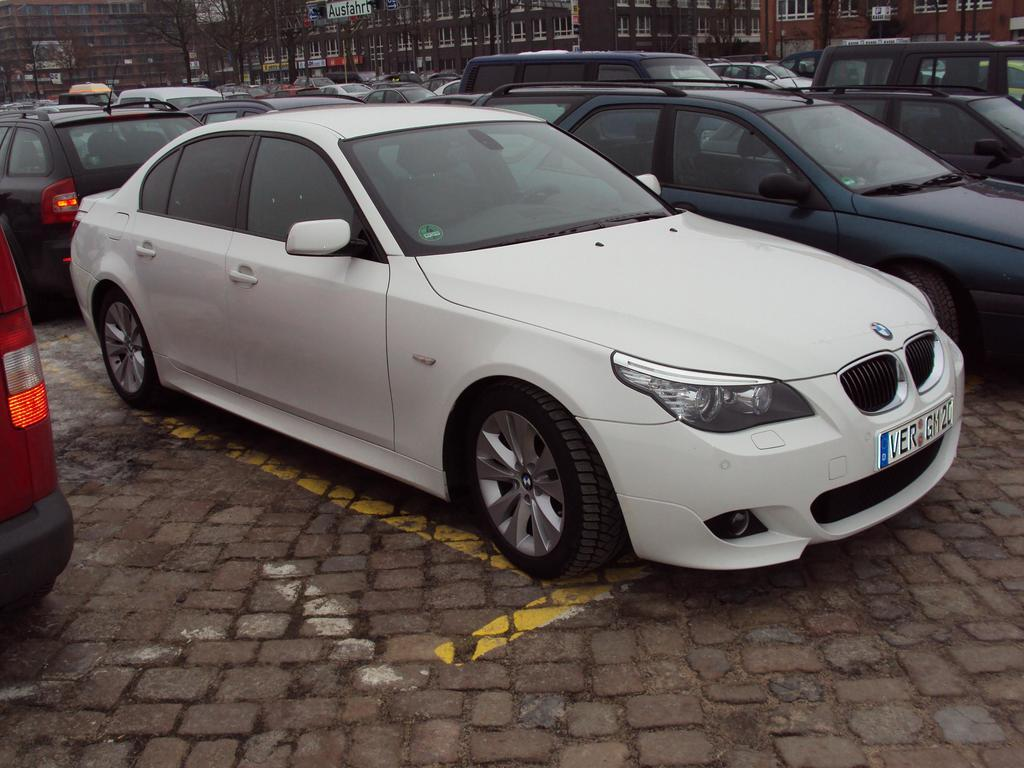What is present on the ground in the image? There are vehicles on the ground in the image. What can be seen in the distance behind the vehicles? There are trees and buildings with windows in the background of the image. Are there any other objects visible in the background? Yes, there are some objects visible in the background of the image. What position does the form take in the image? There is no specific form mentioned in the image, so it's not possible to answer this question. 